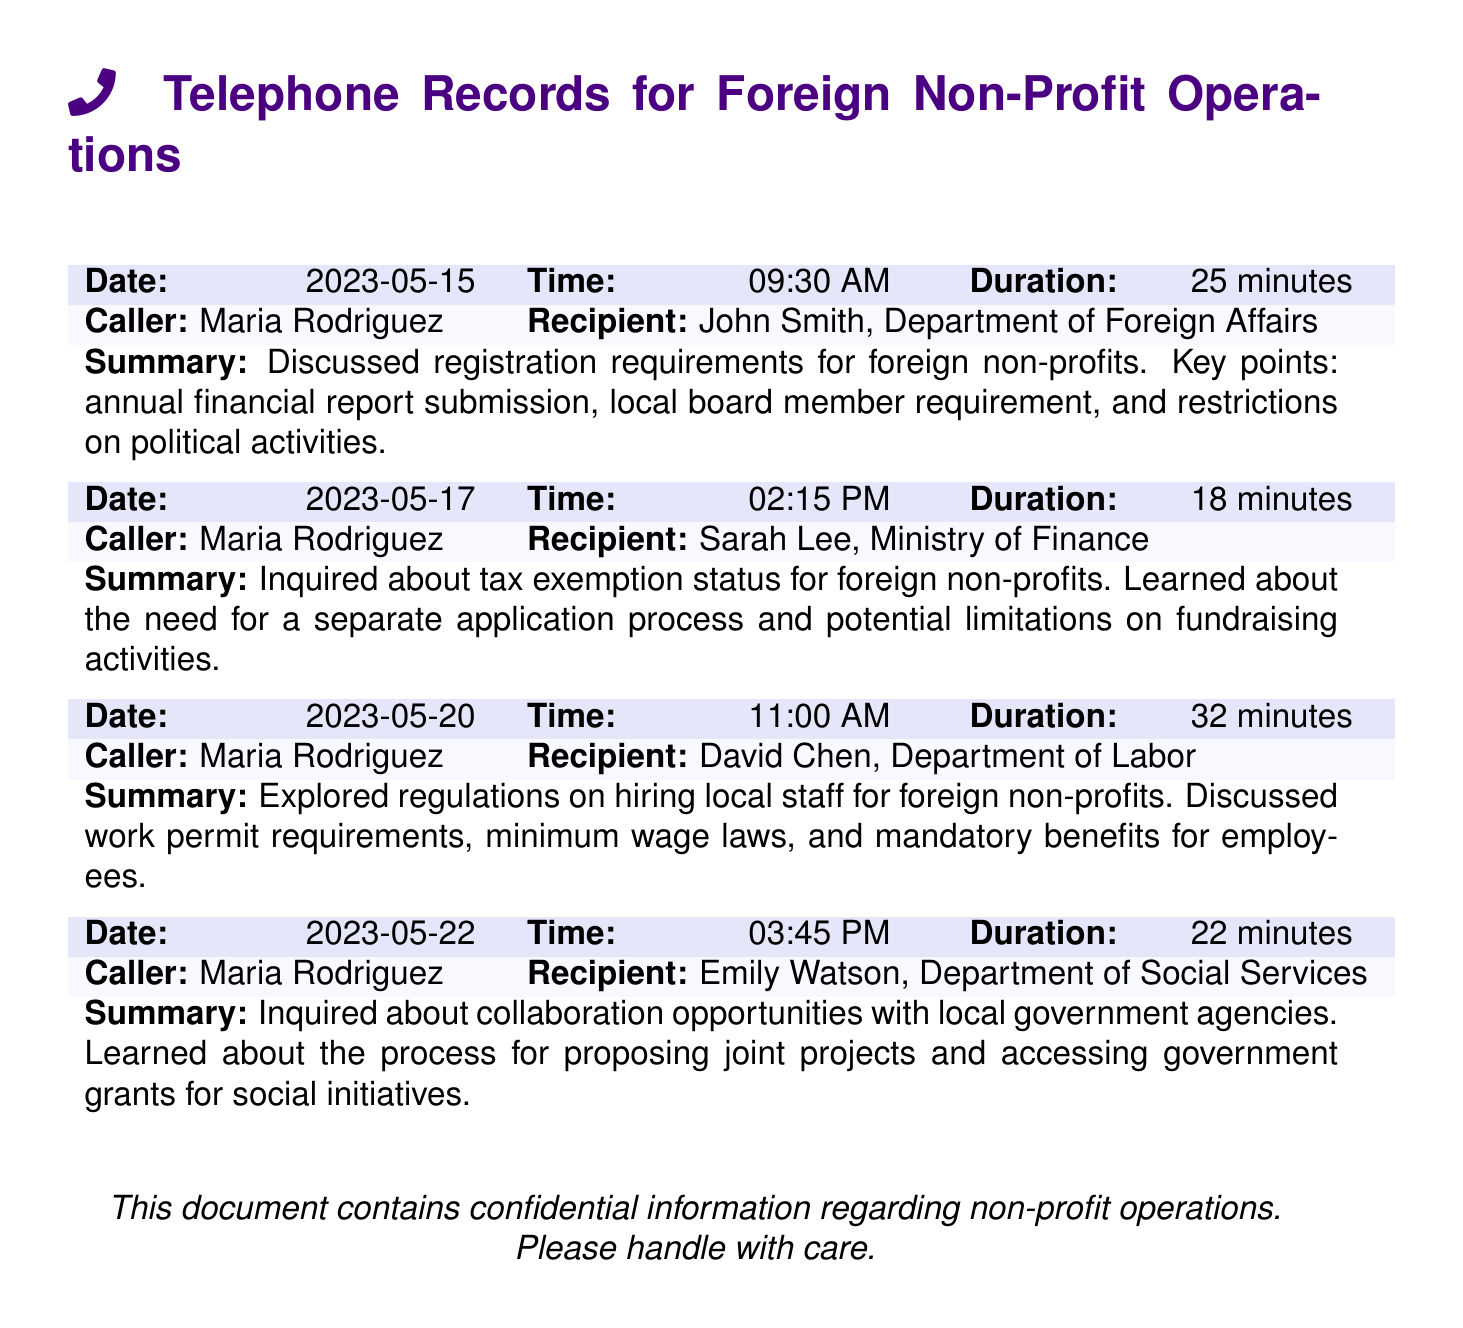What is the date of the first phone call? The first phone call was made on May 15, 2023.
Answer: May 15, 2023 Who was the recipient in the call about tax exemption status? The recipient of the call about tax exemption status was Sarah Lee, Ministry of Finance.
Answer: Sarah Lee, Ministry of Finance What was discussed in the call with David Chen? The call with David Chen discussed regulations on hiring local staff for foreign non-profits.
Answer: Hiring local staff regulations How many minutes did the conversation with John Smith last? The duration of the conversation with John Smith was 25 minutes.
Answer: 25 minutes What is a requirement mentioned in the call with John Smith related to foreign non-profits? The requirement mentioned was the local board member requirement.
Answer: Local board member requirement What can foreign non-profits apply for according to the summary of the call with Emily Watson? They can apply for government grants for social initiatives.
Answer: Government grants What is the total duration of all phone calls summarized? The total duration is the sum of all call durations: 25 + 18 + 32 + 22 = 97 minutes.
Answer: 97 minutes Which department was involved in the call about collaboration opportunities? The department involved was the Department of Social Services.
Answer: Department of Social Services 